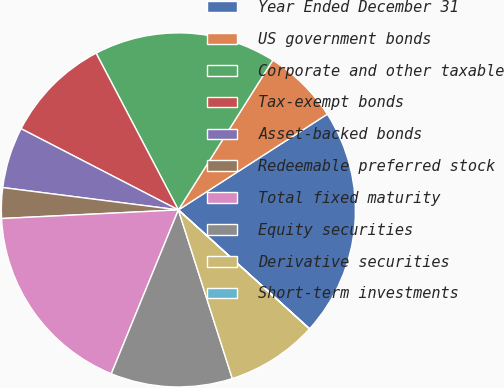<chart> <loc_0><loc_0><loc_500><loc_500><pie_chart><fcel>Year Ended December 31<fcel>US government bonds<fcel>Corporate and other taxable<fcel>Tax-exempt bonds<fcel>Asset-backed bonds<fcel>Redeemable preferred stock<fcel>Total fixed maturity<fcel>Equity securities<fcel>Derivative securities<fcel>Short-term investments<nl><fcel>20.81%<fcel>6.95%<fcel>16.65%<fcel>9.72%<fcel>5.57%<fcel>2.79%<fcel>18.04%<fcel>11.11%<fcel>8.34%<fcel>0.02%<nl></chart> 